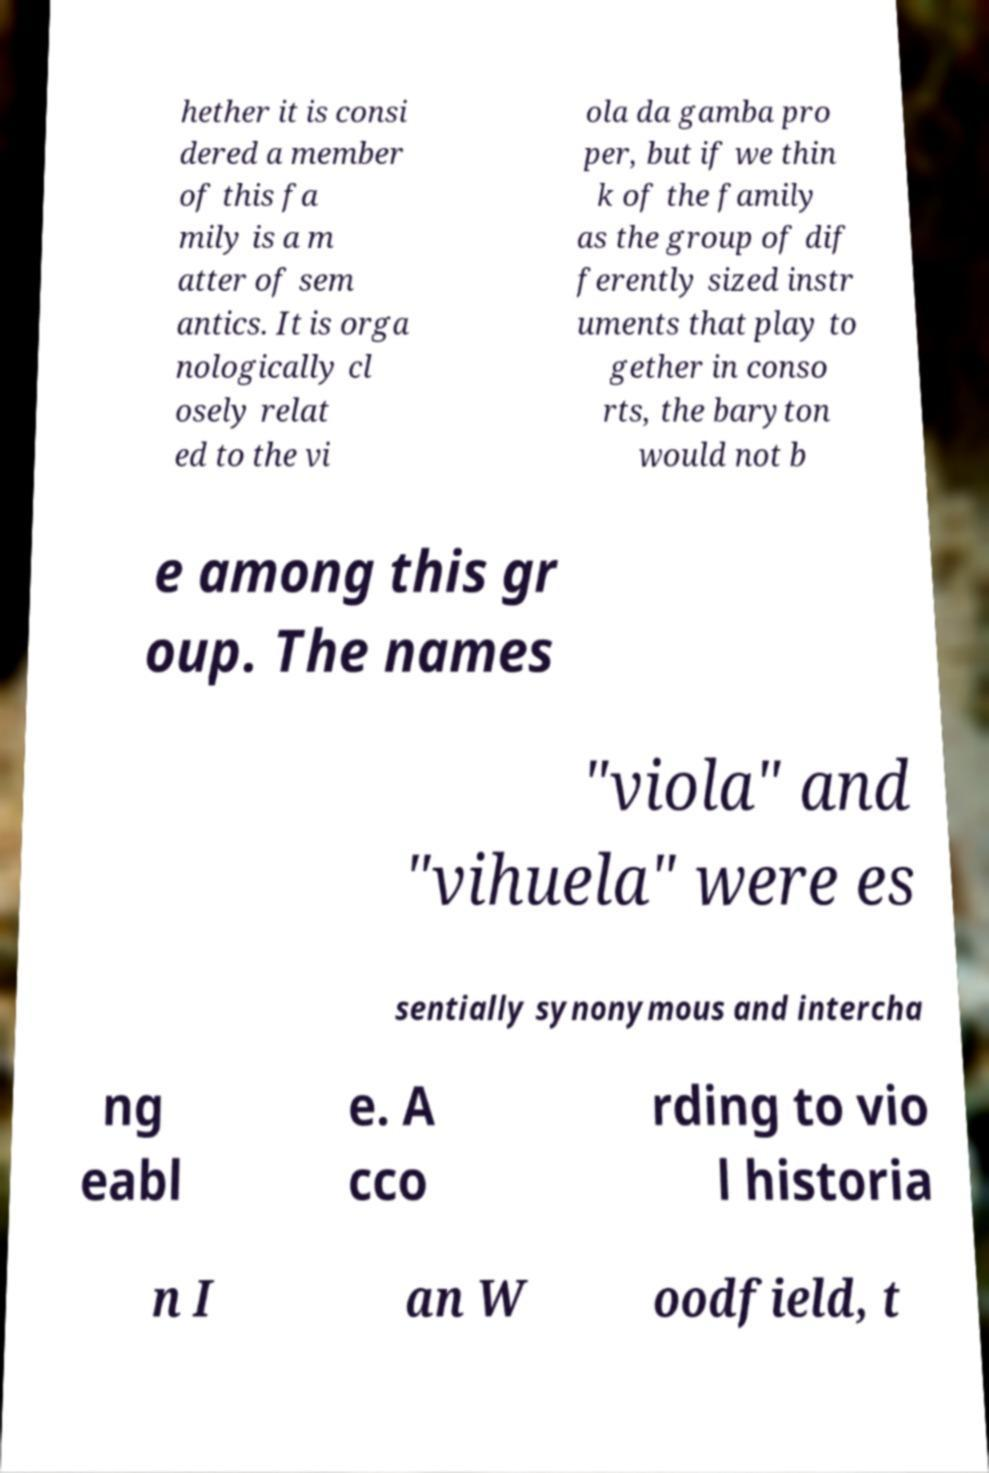For documentation purposes, I need the text within this image transcribed. Could you provide that? hether it is consi dered a member of this fa mily is a m atter of sem antics. It is orga nologically cl osely relat ed to the vi ola da gamba pro per, but if we thin k of the family as the group of dif ferently sized instr uments that play to gether in conso rts, the baryton would not b e among this gr oup. The names "viola" and "vihuela" were es sentially synonymous and intercha ng eabl e. A cco rding to vio l historia n I an W oodfield, t 